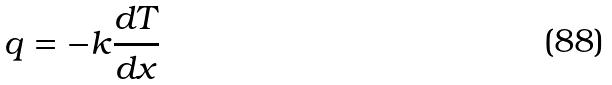<formula> <loc_0><loc_0><loc_500><loc_500>q = - k \frac { d T } { d x }</formula> 